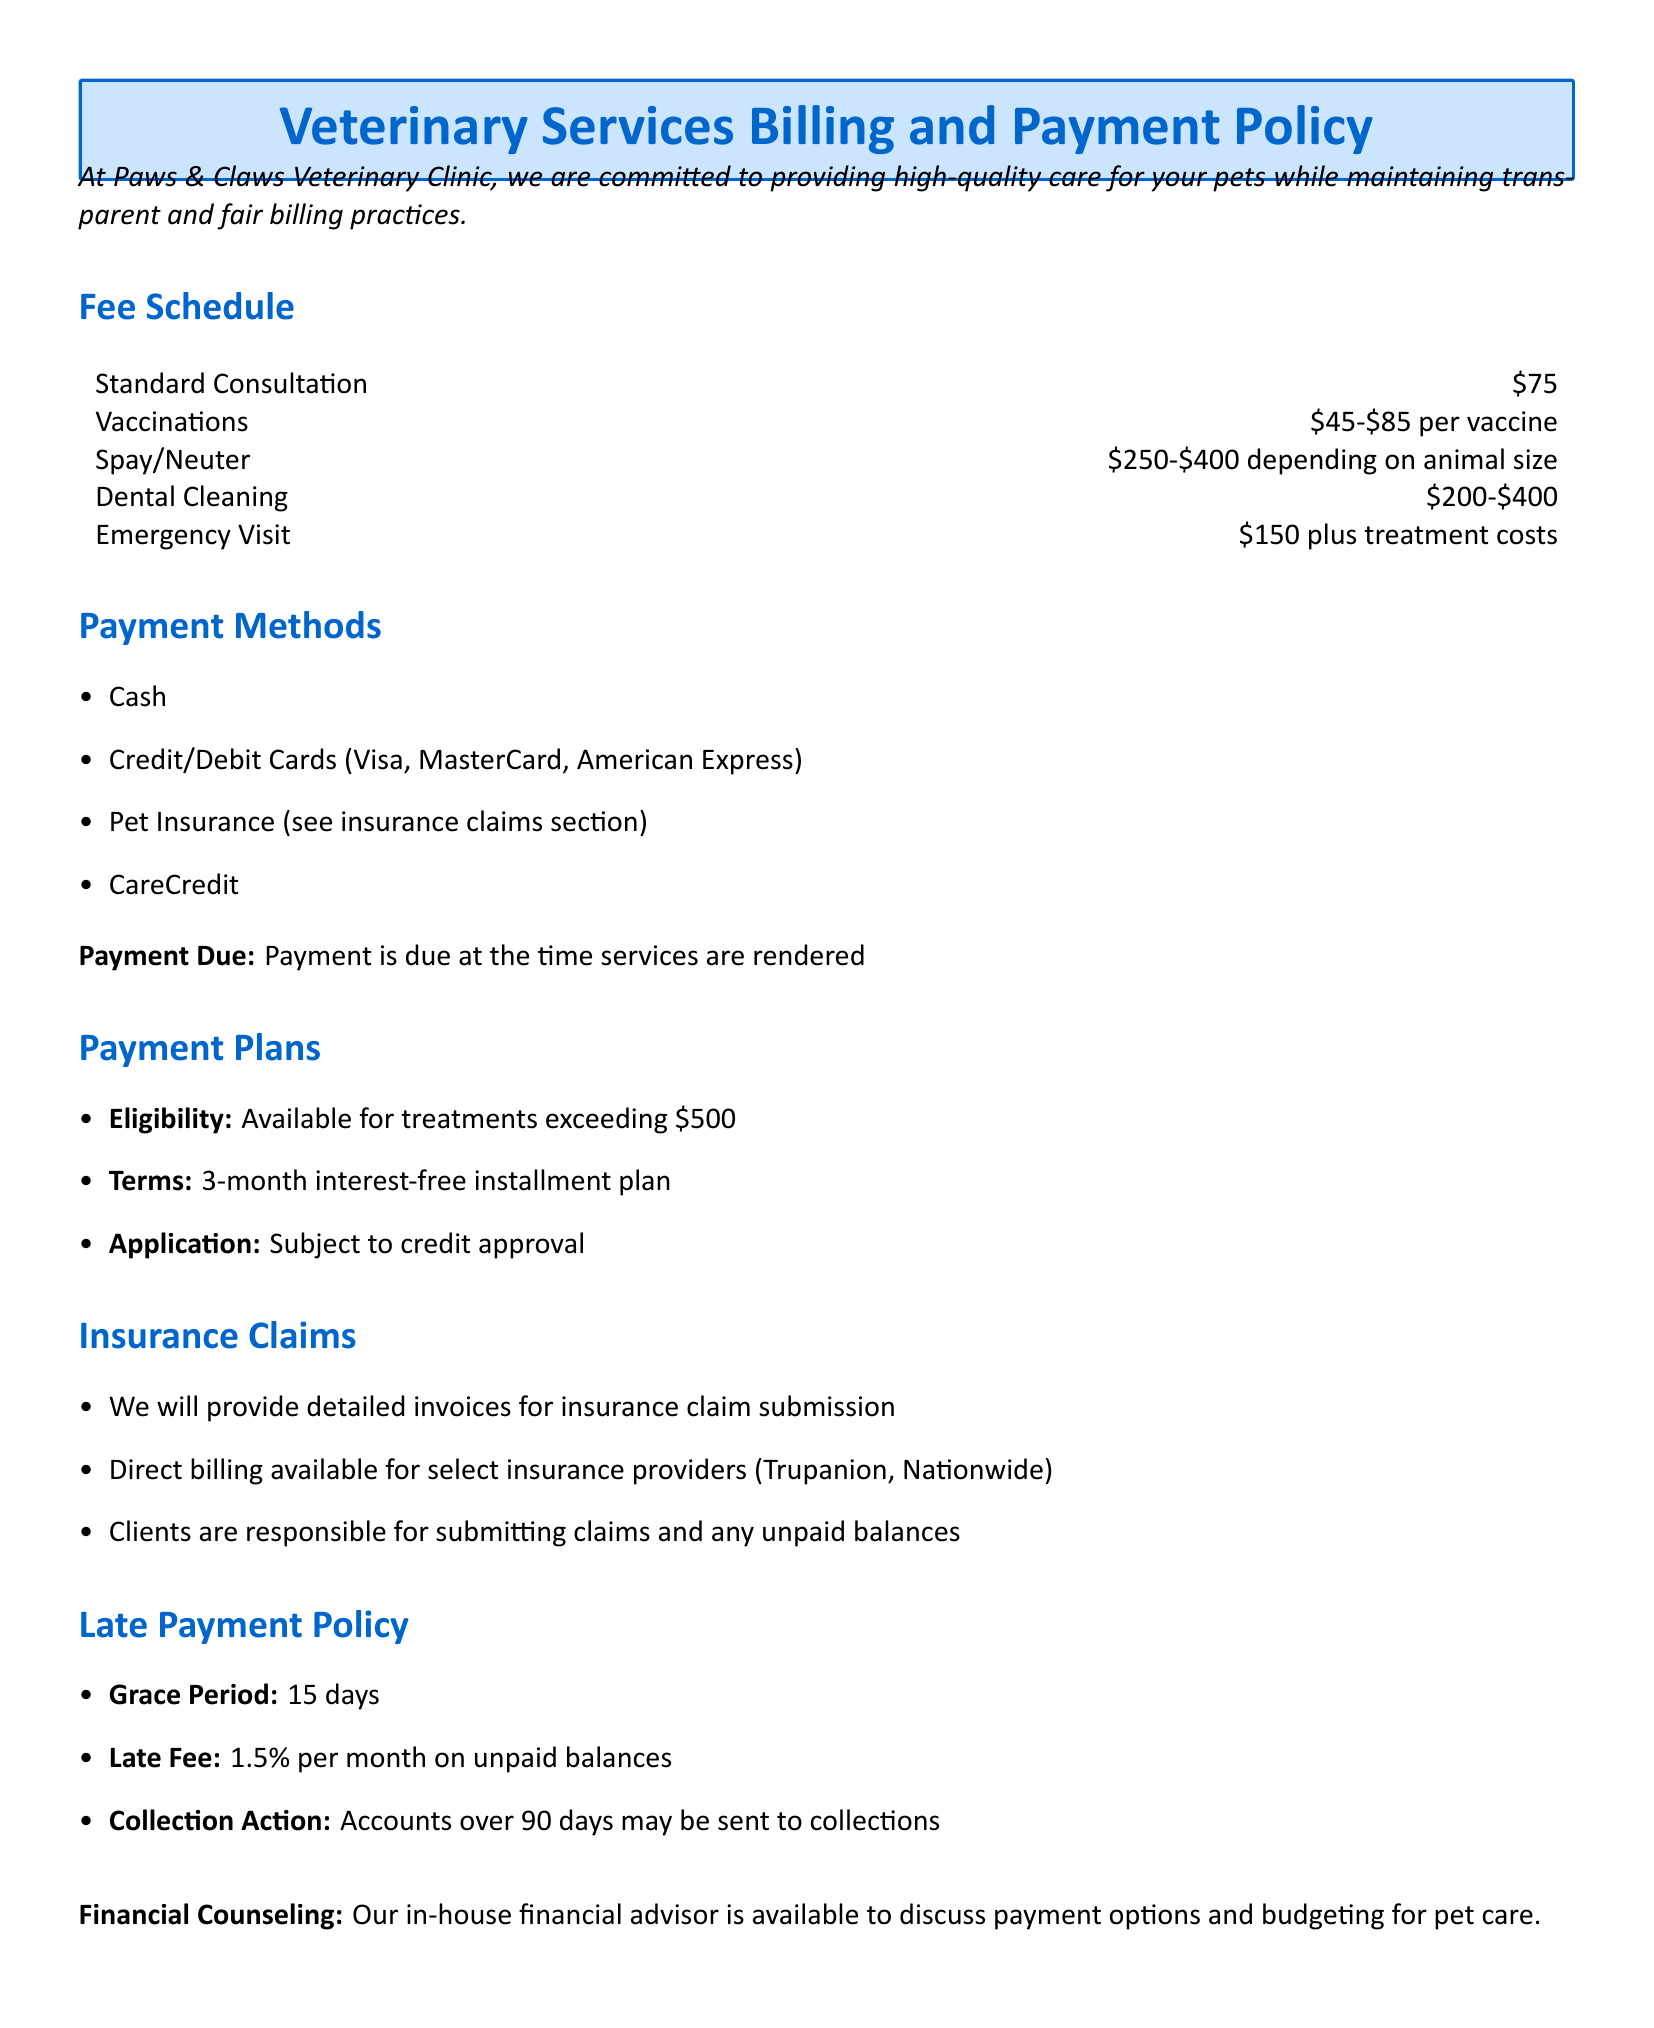What is the fee for a standard consultation? The fee schedule lists the cost for a standard consultation specifically.
Answer: $75 What is the interest-free installment term for payment plans? The policy outlines terms for payment plans in the payment plans section.
Answer: 3-month What is the late fee percentage for unpaid balances? The late payment policy section provides details about late fees.
Answer: 1.5% Are credit card payments accepted? The payment methods section indicates accepted payment forms.
Answer: Yes What is the minimum treatment cost eligibility for payment plans? The payment plans section specifies eligibility conditions based on treatment costs.
Answer: $500 Which pet insurance providers offer direct billing? The insurance claims section mentions specific providers for direct billing.
Answer: Trupanion, Nationwide What is the grace period for late payments? The late payment policy outlines the grace period explicitly.
Answer: 15 days How much does an emergency visit cost? The fee schedule details the cost for an emergency visit.
Answer: $150 plus treatment costs What is the cost range for vaccinations? The fee schedule provides a range for vaccination costs.
Answer: $45-$85 per vaccine 